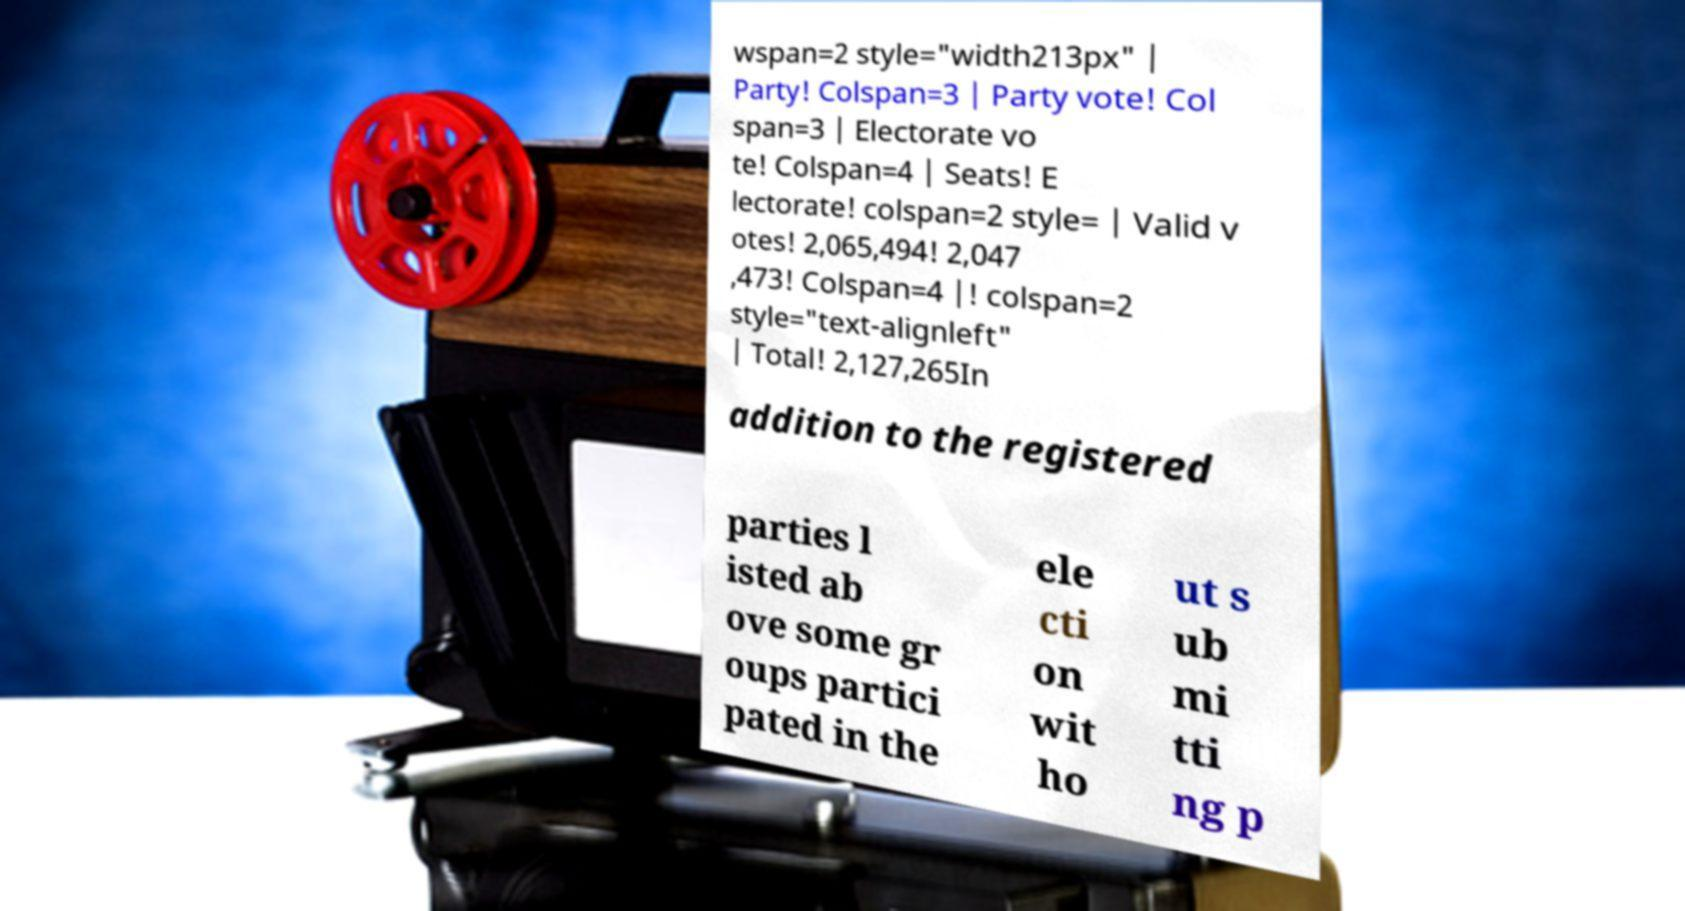Could you extract and type out the text from this image? wspan=2 style="width213px" | Party! Colspan=3 | Party vote! Col span=3 | Electorate vo te! Colspan=4 | Seats! E lectorate! colspan=2 style= | Valid v otes! 2,065,494! 2,047 ,473! Colspan=4 |! colspan=2 style="text-alignleft" | Total! 2,127,265In addition to the registered parties l isted ab ove some gr oups partici pated in the ele cti on wit ho ut s ub mi tti ng p 